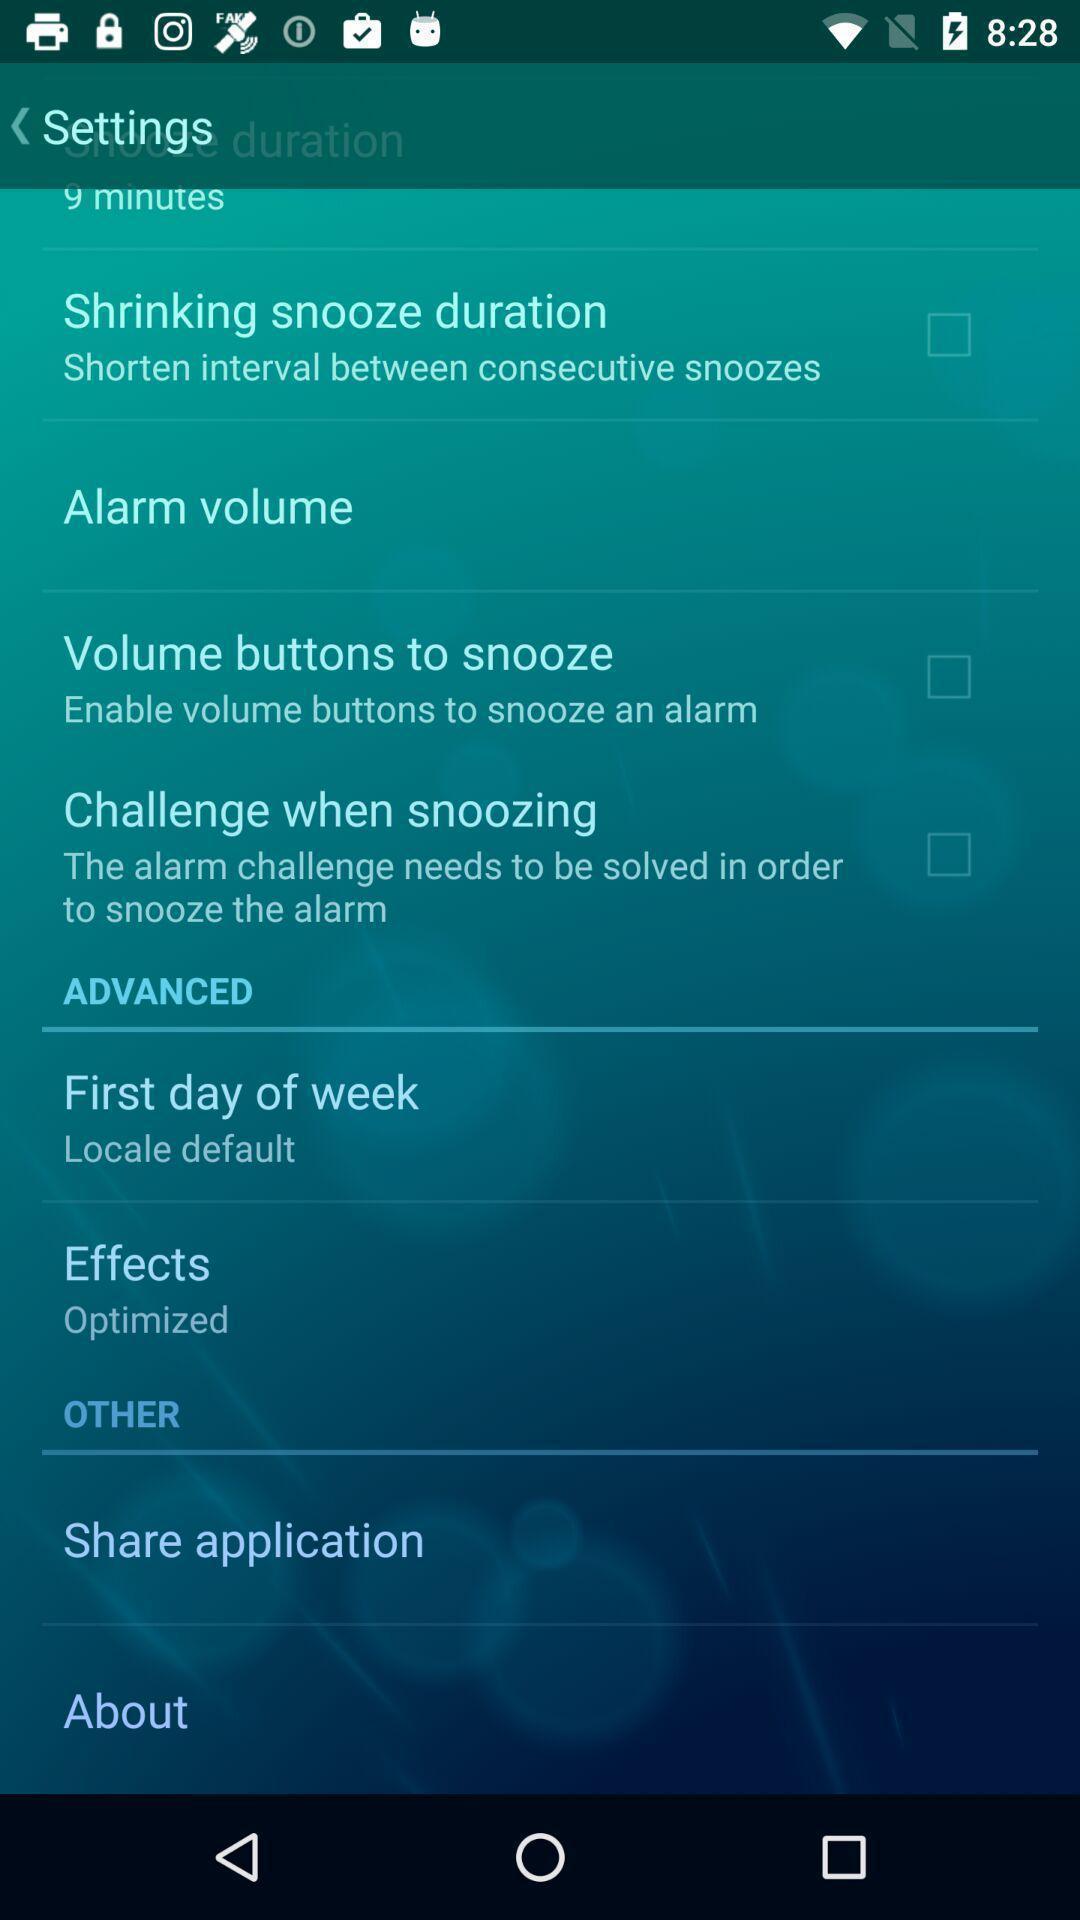Describe the content in this image. Settings page. 